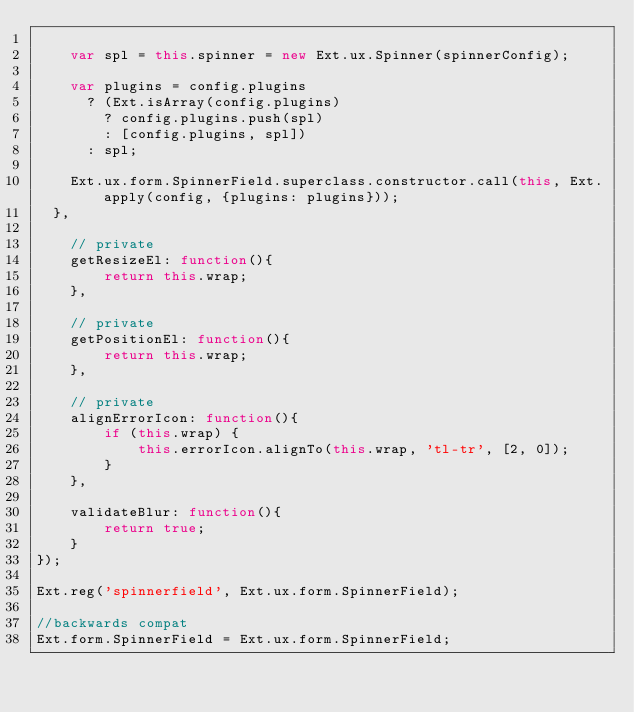<code> <loc_0><loc_0><loc_500><loc_500><_JavaScript_>
		var spl = this.spinner = new Ext.ux.Spinner(spinnerConfig);

		var plugins = config.plugins
			? (Ext.isArray(config.plugins)
				? config.plugins.push(spl)
				: [config.plugins, spl])
			: spl;

		Ext.ux.form.SpinnerField.superclass.constructor.call(this, Ext.apply(config, {plugins: plugins}));
	},

    // private
    getResizeEl: function(){
        return this.wrap;
    },

    // private
    getPositionEl: function(){
        return this.wrap;
    },

    // private
    alignErrorIcon: function(){
        if (this.wrap) {
            this.errorIcon.alignTo(this.wrap, 'tl-tr', [2, 0]);
        }
    },

    validateBlur: function(){
        return true;
    }
});

Ext.reg('spinnerfield', Ext.ux.form.SpinnerField);

//backwards compat
Ext.form.SpinnerField = Ext.ux.form.SpinnerField;
</code> 